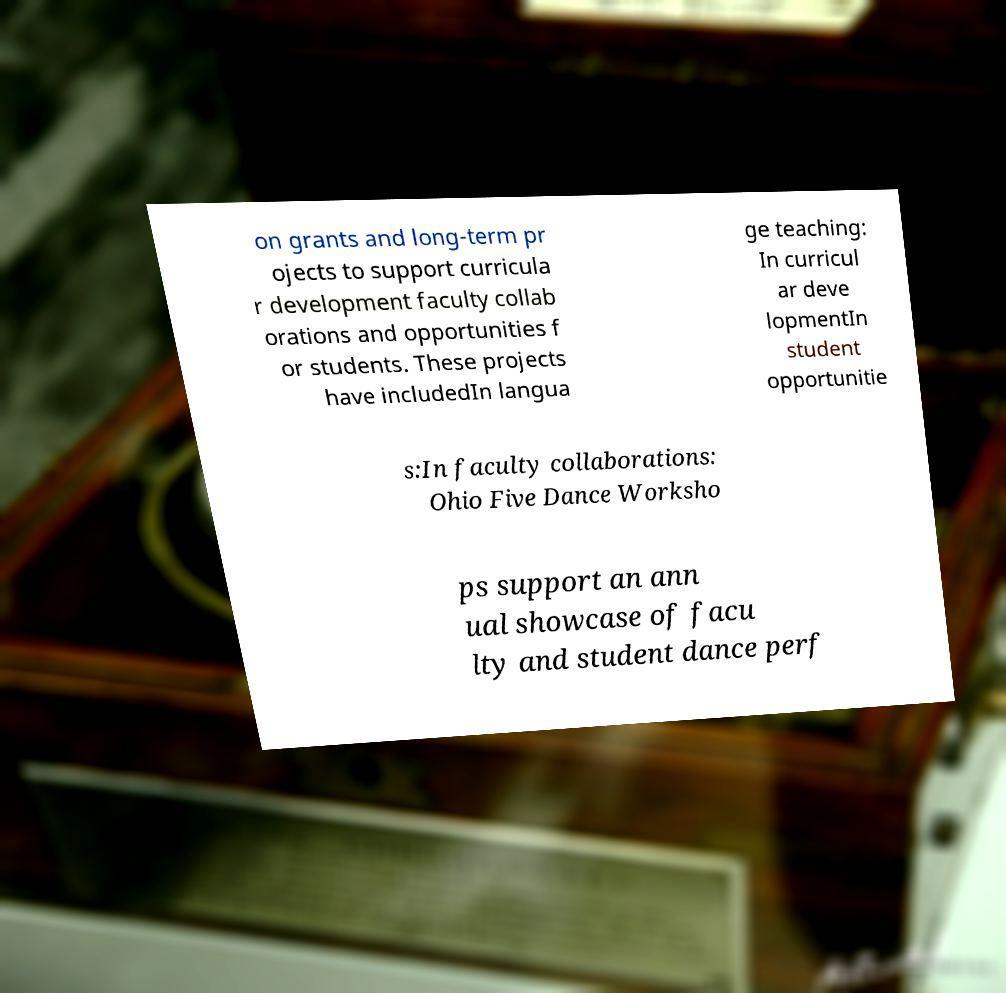Please read and relay the text visible in this image. What does it say? on grants and long-term pr ojects to support curricula r development faculty collab orations and opportunities f or students. These projects have includedIn langua ge teaching: In curricul ar deve lopmentIn student opportunitie s:In faculty collaborations: Ohio Five Dance Worksho ps support an ann ual showcase of facu lty and student dance perf 